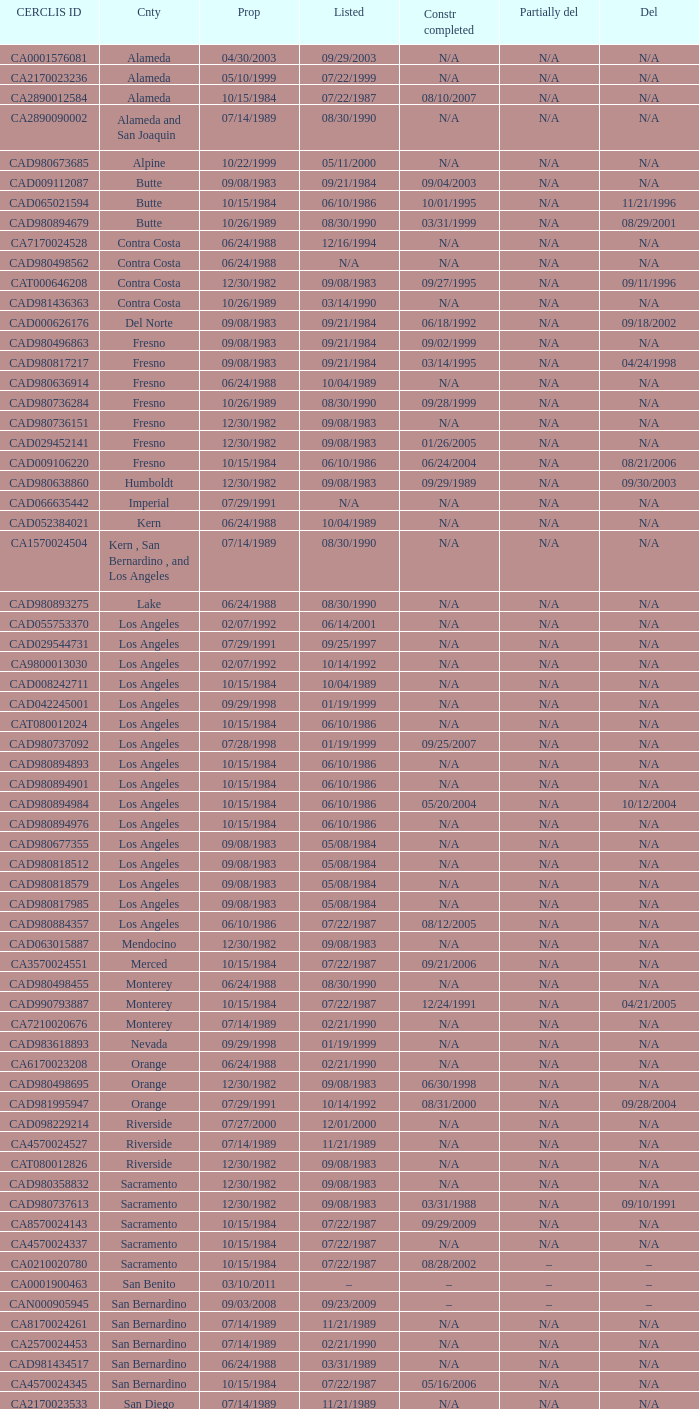What construction completed on 08/10/2007? 07/22/1987. 